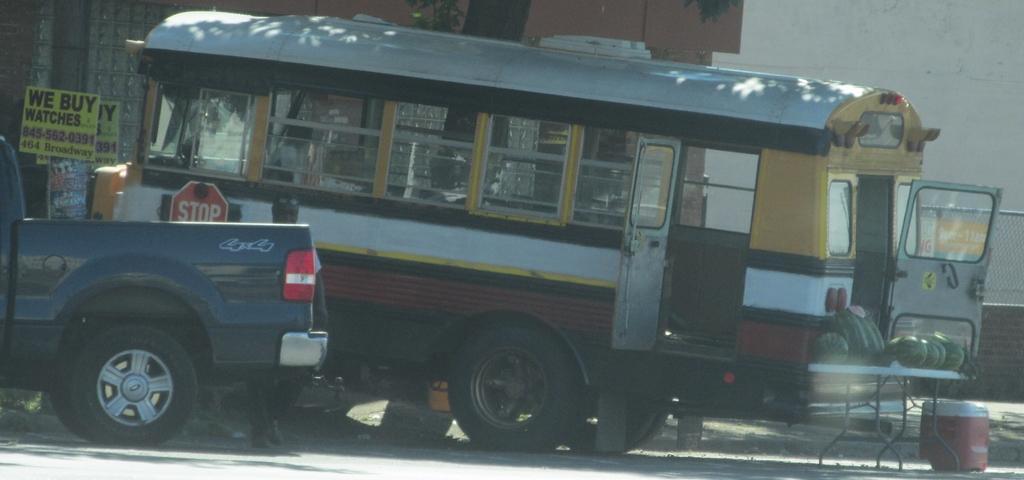Please provide a concise description of this image. In the picture we can see a bus with an opened door and near to it, we can see a table on it, we can see some watermelons and near the table, we can see a box on the path and besides the bus we can see a car which is blue in color and a stop board and in the background we can see a wall. 